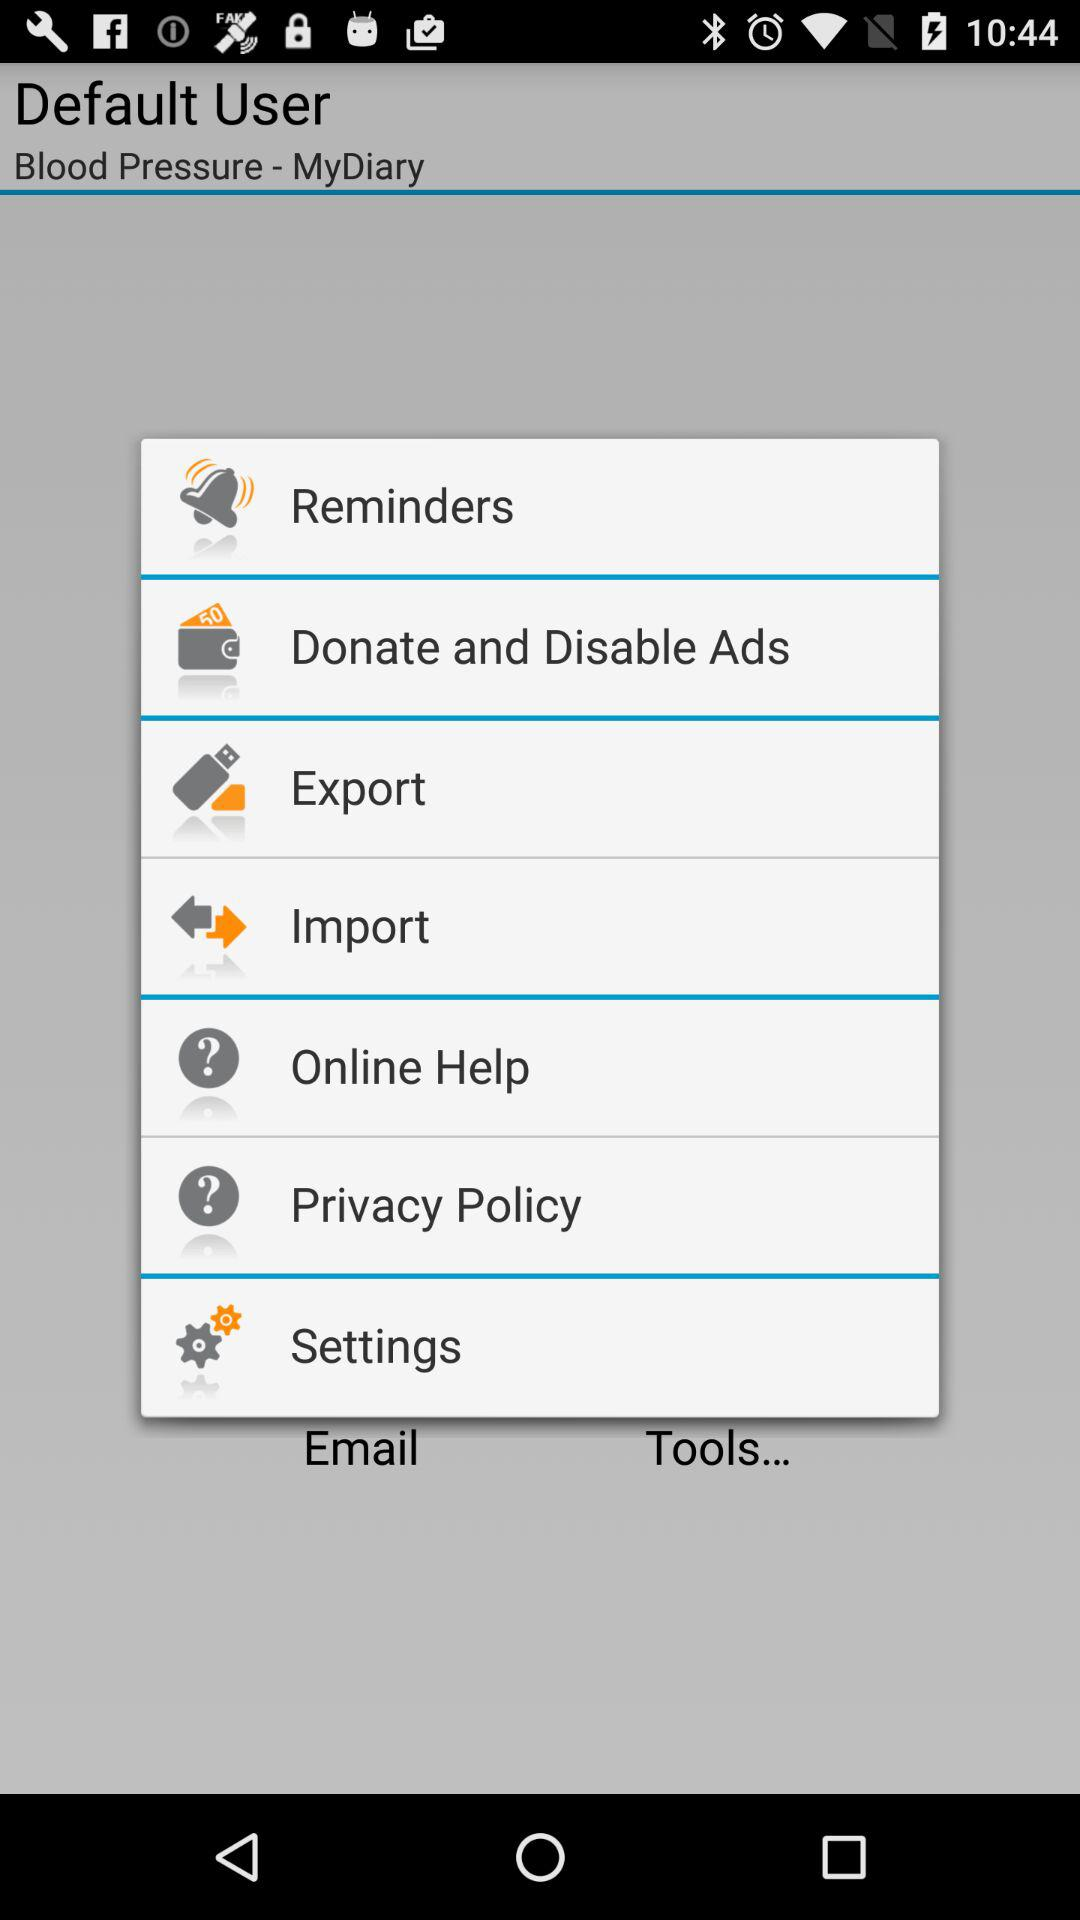What account is the user logging in with? The user is logging in with the default account. 